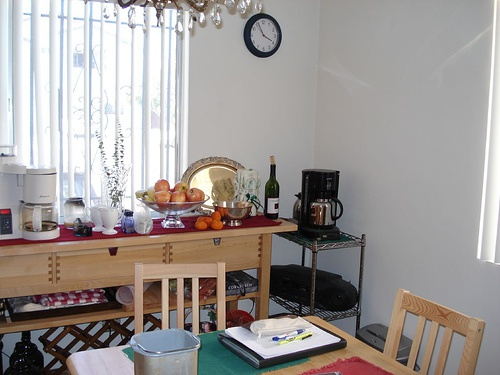Describe the objects in this image and their specific colors. I can see dining table in lightgray, teal, tan, lavender, and brown tones, chair in lightgray, gray, tan, and darkgray tones, chair in lightgray, tan, and gray tones, bowl in lightgray, brown, gray, darkgray, and tan tones, and potted plant in lightgray, white, darkgray, and gray tones in this image. 